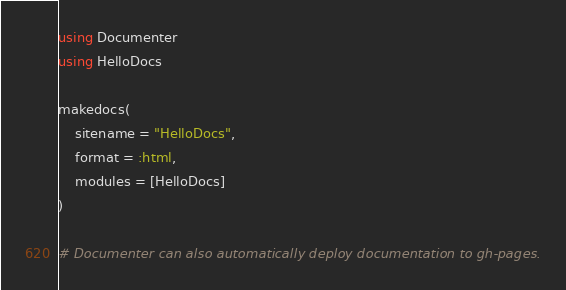Convert code to text. <code><loc_0><loc_0><loc_500><loc_500><_Julia_>using Documenter
using HelloDocs

makedocs(
    sitename = "HelloDocs",
    format = :html,
    modules = [HelloDocs]
)

# Documenter can also automatically deploy documentation to gh-pages.</code> 